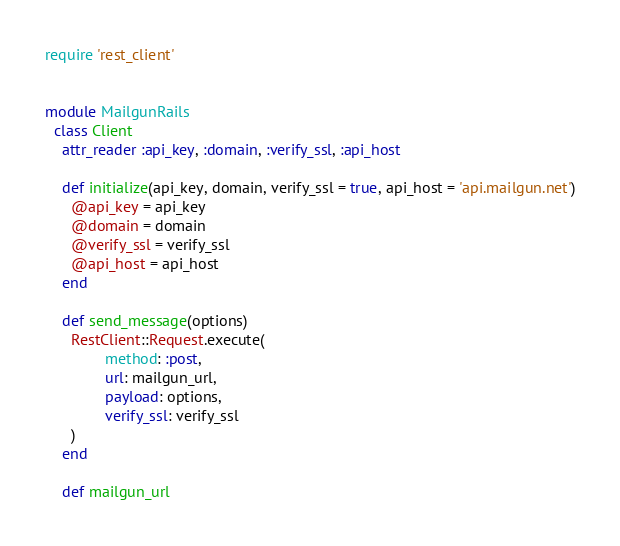Convert code to text. <code><loc_0><loc_0><loc_500><loc_500><_Ruby_>require 'rest_client'


module MailgunRails
  class Client
    attr_reader :api_key, :domain, :verify_ssl, :api_host

    def initialize(api_key, domain, verify_ssl = true, api_host = 'api.mailgun.net')
      @api_key = api_key
      @domain = domain
      @verify_ssl = verify_ssl
      @api_host = api_host
    end

    def send_message(options)
      RestClient::Request.execute(
              method: :post,
              url: mailgun_url,
              payload: options,
              verify_ssl: verify_ssl
      )
    end

    def mailgun_url</code> 